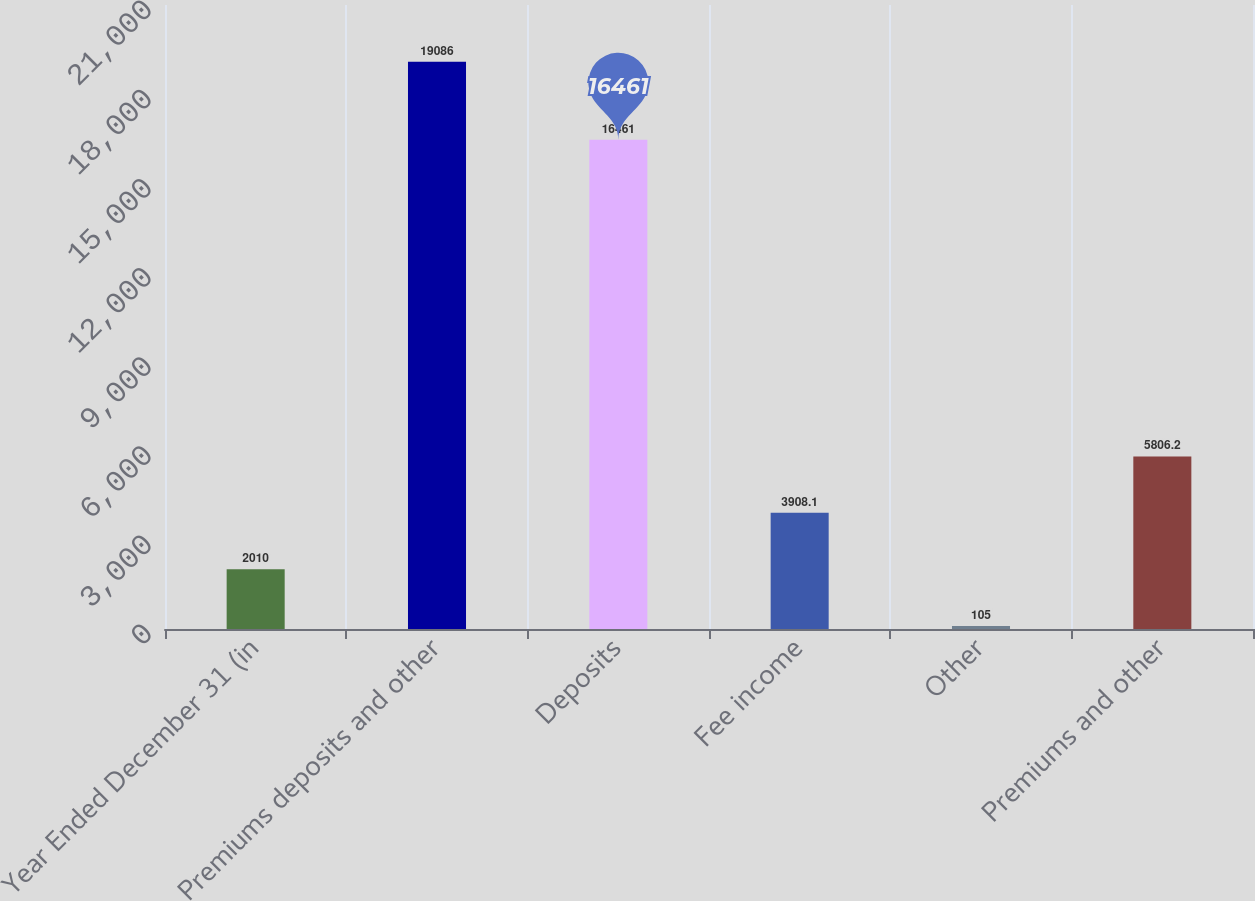Convert chart to OTSL. <chart><loc_0><loc_0><loc_500><loc_500><bar_chart><fcel>Year Ended December 31 (in<fcel>Premiums deposits and other<fcel>Deposits<fcel>Fee income<fcel>Other<fcel>Premiums and other<nl><fcel>2010<fcel>19086<fcel>16461<fcel>3908.1<fcel>105<fcel>5806.2<nl></chart> 